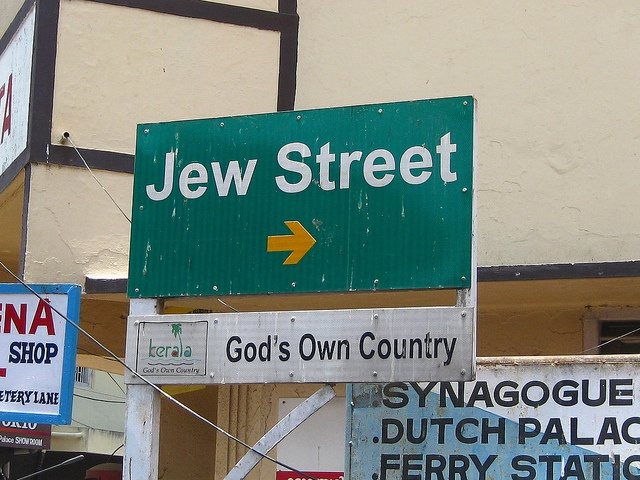Describe the objects in this image and their specific colors. I can see various objects in this image with different colors. 